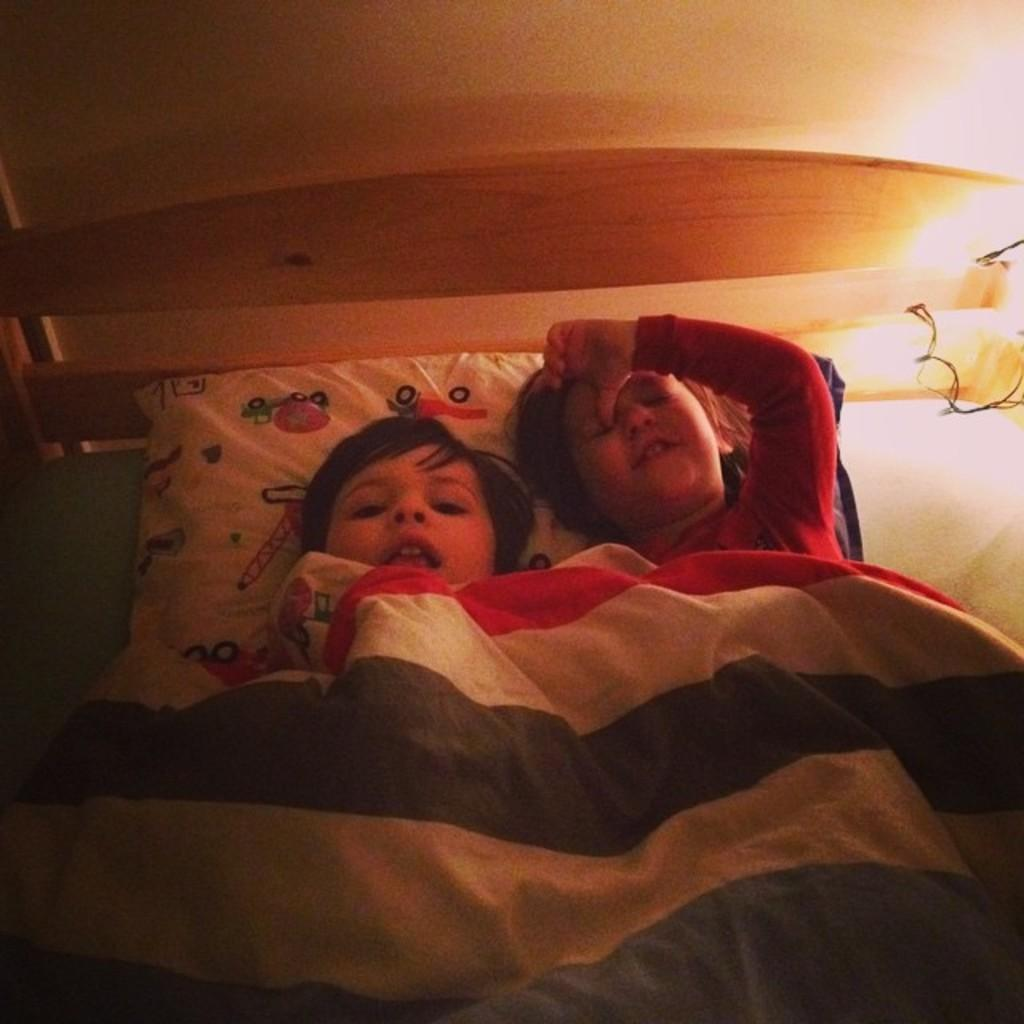How many kids are present in the image? There are two kids in the image. What are the kids doing in the image? The kids are lying on a bed. What is covering the kids in the image? Both kids are under a blanket. Can you describe the lighting in the image? There is a light on the right side of the image. What type of pillow can be seen in the image? There is a white pillow with some designs in the image. What type of marble game is the aunt playing with the kids in the image? There is no aunt or marble game present in the image. 